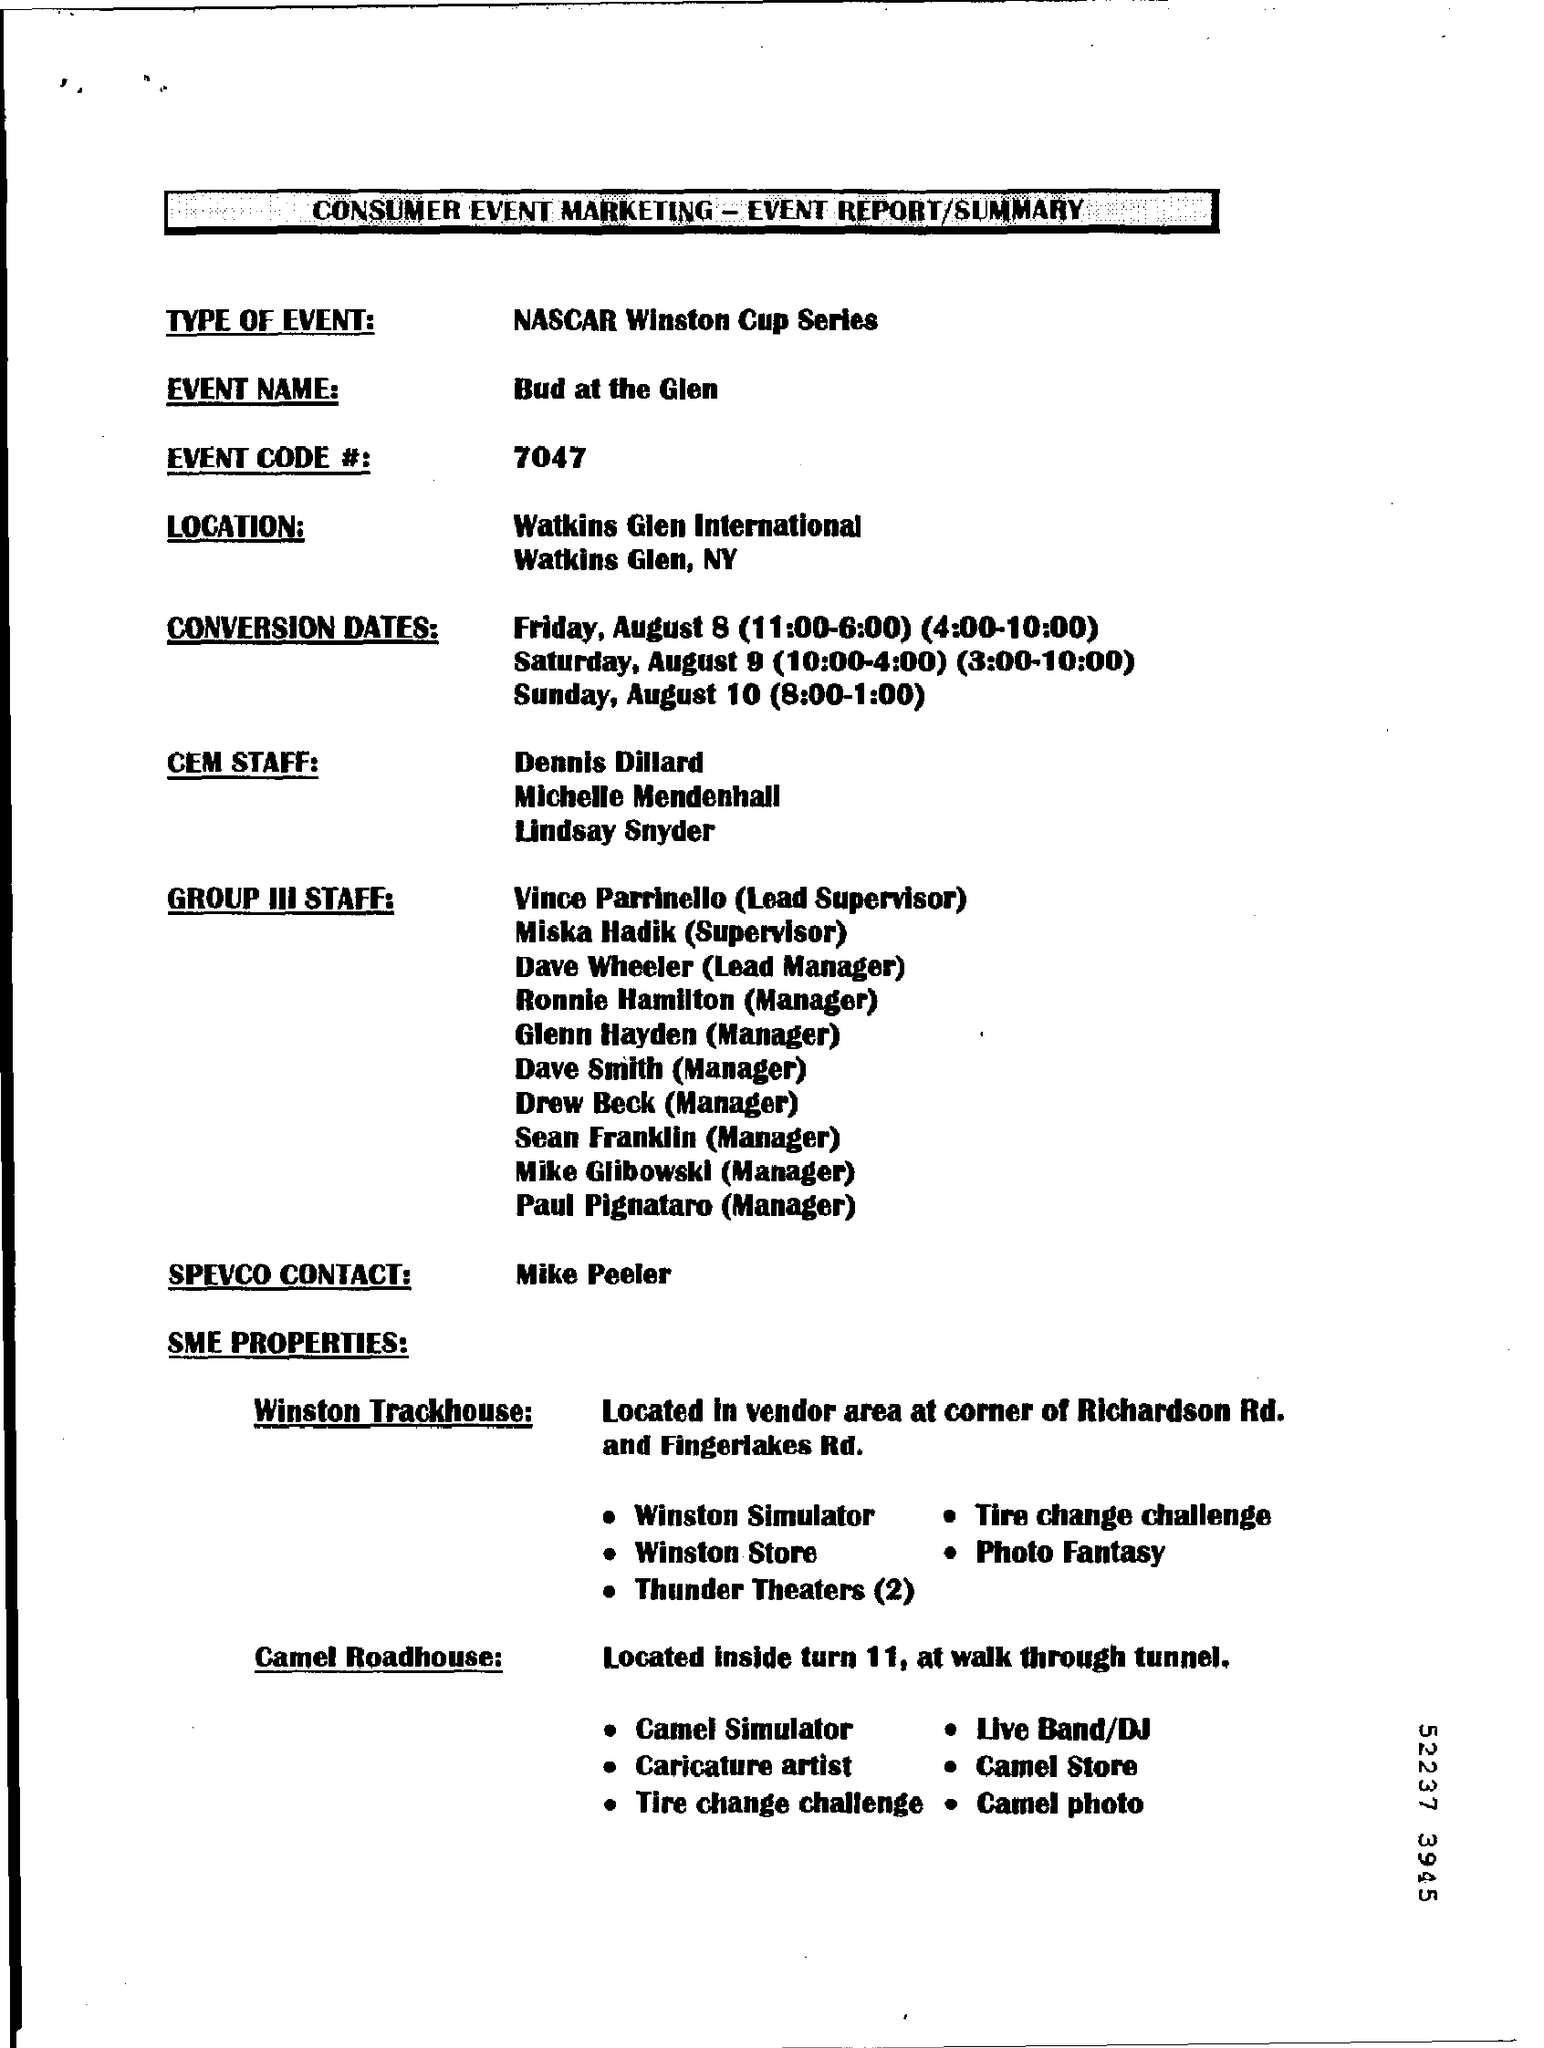Mention a couple of crucial points in this snapshot. The individual referred to as the SPEVCO Contact is Mike Peeler. The Event name is "Bud at the Glen. The event code is #7047. Turn 11 at the walk-through tunnel contains the Camel Roadhouse, a location that can be accessed by pedestrians. The event in question is a NASCAR Winston Cup Series, a type of automotive racing competition. 